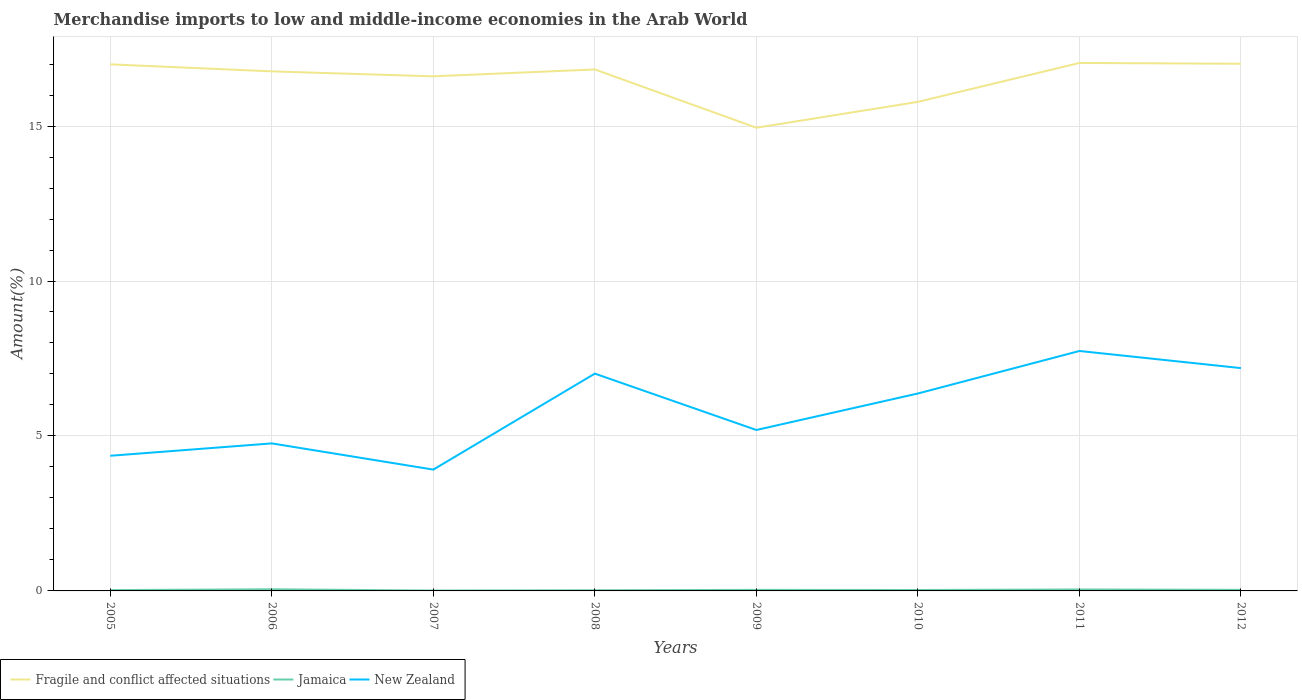How many different coloured lines are there?
Provide a succinct answer. 3. Does the line corresponding to New Zealand intersect with the line corresponding to Jamaica?
Offer a very short reply. No. Across all years, what is the maximum percentage of amount earned from merchandise imports in Fragile and conflict affected situations?
Provide a succinct answer. 14.95. In which year was the percentage of amount earned from merchandise imports in New Zealand maximum?
Keep it short and to the point. 2007. What is the total percentage of amount earned from merchandise imports in New Zealand in the graph?
Provide a short and direct response. -2.01. What is the difference between the highest and the second highest percentage of amount earned from merchandise imports in New Zealand?
Make the answer very short. 3.83. What is the difference between the highest and the lowest percentage of amount earned from merchandise imports in Fragile and conflict affected situations?
Your answer should be compact. 6. How many lines are there?
Your answer should be compact. 3. Are the values on the major ticks of Y-axis written in scientific E-notation?
Provide a succinct answer. No. Where does the legend appear in the graph?
Offer a very short reply. Bottom left. How are the legend labels stacked?
Provide a short and direct response. Horizontal. What is the title of the graph?
Your response must be concise. Merchandise imports to low and middle-income economies in the Arab World. What is the label or title of the X-axis?
Your answer should be compact. Years. What is the label or title of the Y-axis?
Offer a terse response. Amount(%). What is the Amount(%) of Fragile and conflict affected situations in 2005?
Give a very brief answer. 16.99. What is the Amount(%) in Jamaica in 2005?
Provide a succinct answer. 0.03. What is the Amount(%) in New Zealand in 2005?
Offer a very short reply. 4.36. What is the Amount(%) in Fragile and conflict affected situations in 2006?
Your answer should be compact. 16.76. What is the Amount(%) in Jamaica in 2006?
Offer a very short reply. 0.05. What is the Amount(%) of New Zealand in 2006?
Your response must be concise. 4.76. What is the Amount(%) in Fragile and conflict affected situations in 2007?
Provide a short and direct response. 16.6. What is the Amount(%) in Jamaica in 2007?
Your response must be concise. 0.01. What is the Amount(%) in New Zealand in 2007?
Offer a very short reply. 3.91. What is the Amount(%) in Fragile and conflict affected situations in 2008?
Offer a very short reply. 16.83. What is the Amount(%) of Jamaica in 2008?
Your answer should be very brief. 0.02. What is the Amount(%) in New Zealand in 2008?
Your response must be concise. 7.01. What is the Amount(%) of Fragile and conflict affected situations in 2009?
Your answer should be compact. 14.95. What is the Amount(%) in Jamaica in 2009?
Give a very brief answer. 0.03. What is the Amount(%) of New Zealand in 2009?
Offer a terse response. 5.19. What is the Amount(%) of Fragile and conflict affected situations in 2010?
Your answer should be compact. 15.78. What is the Amount(%) of Jamaica in 2010?
Give a very brief answer. 0.03. What is the Amount(%) in New Zealand in 2010?
Give a very brief answer. 6.37. What is the Amount(%) in Fragile and conflict affected situations in 2011?
Your answer should be compact. 17.04. What is the Amount(%) of Jamaica in 2011?
Provide a succinct answer. 0.05. What is the Amount(%) of New Zealand in 2011?
Offer a very short reply. 7.74. What is the Amount(%) in Fragile and conflict affected situations in 2012?
Your response must be concise. 17.01. What is the Amount(%) in Jamaica in 2012?
Ensure brevity in your answer.  0.03. What is the Amount(%) of New Zealand in 2012?
Your answer should be compact. 7.19. Across all years, what is the maximum Amount(%) in Fragile and conflict affected situations?
Your answer should be compact. 17.04. Across all years, what is the maximum Amount(%) in Jamaica?
Your answer should be compact. 0.05. Across all years, what is the maximum Amount(%) in New Zealand?
Offer a very short reply. 7.74. Across all years, what is the minimum Amount(%) in Fragile and conflict affected situations?
Make the answer very short. 14.95. Across all years, what is the minimum Amount(%) in Jamaica?
Your answer should be very brief. 0.01. Across all years, what is the minimum Amount(%) of New Zealand?
Make the answer very short. 3.91. What is the total Amount(%) of Fragile and conflict affected situations in the graph?
Ensure brevity in your answer.  131.96. What is the total Amount(%) of Jamaica in the graph?
Your answer should be very brief. 0.26. What is the total Amount(%) in New Zealand in the graph?
Keep it short and to the point. 46.54. What is the difference between the Amount(%) of Fragile and conflict affected situations in 2005 and that in 2006?
Give a very brief answer. 0.23. What is the difference between the Amount(%) in Jamaica in 2005 and that in 2006?
Make the answer very short. -0.03. What is the difference between the Amount(%) of New Zealand in 2005 and that in 2006?
Give a very brief answer. -0.4. What is the difference between the Amount(%) of Fragile and conflict affected situations in 2005 and that in 2007?
Offer a very short reply. 0.39. What is the difference between the Amount(%) in Jamaica in 2005 and that in 2007?
Your response must be concise. 0.01. What is the difference between the Amount(%) in New Zealand in 2005 and that in 2007?
Your response must be concise. 0.45. What is the difference between the Amount(%) in Fragile and conflict affected situations in 2005 and that in 2008?
Keep it short and to the point. 0.16. What is the difference between the Amount(%) of Jamaica in 2005 and that in 2008?
Keep it short and to the point. 0.01. What is the difference between the Amount(%) in New Zealand in 2005 and that in 2008?
Give a very brief answer. -2.65. What is the difference between the Amount(%) in Fragile and conflict affected situations in 2005 and that in 2009?
Give a very brief answer. 2.04. What is the difference between the Amount(%) in Jamaica in 2005 and that in 2009?
Your answer should be very brief. -0.01. What is the difference between the Amount(%) in New Zealand in 2005 and that in 2009?
Your answer should be compact. -0.83. What is the difference between the Amount(%) in Fragile and conflict affected situations in 2005 and that in 2010?
Make the answer very short. 1.21. What is the difference between the Amount(%) in Jamaica in 2005 and that in 2010?
Your answer should be compact. -0. What is the difference between the Amount(%) in New Zealand in 2005 and that in 2010?
Give a very brief answer. -2.01. What is the difference between the Amount(%) of Fragile and conflict affected situations in 2005 and that in 2011?
Ensure brevity in your answer.  -0.04. What is the difference between the Amount(%) in Jamaica in 2005 and that in 2011?
Keep it short and to the point. -0.02. What is the difference between the Amount(%) of New Zealand in 2005 and that in 2011?
Ensure brevity in your answer.  -3.38. What is the difference between the Amount(%) in Fragile and conflict affected situations in 2005 and that in 2012?
Offer a terse response. -0.02. What is the difference between the Amount(%) of Jamaica in 2005 and that in 2012?
Offer a very short reply. -0.01. What is the difference between the Amount(%) in New Zealand in 2005 and that in 2012?
Offer a terse response. -2.83. What is the difference between the Amount(%) of Fragile and conflict affected situations in 2006 and that in 2007?
Your answer should be compact. 0.16. What is the difference between the Amount(%) in Jamaica in 2006 and that in 2007?
Your answer should be very brief. 0.04. What is the difference between the Amount(%) in New Zealand in 2006 and that in 2007?
Offer a terse response. 0.85. What is the difference between the Amount(%) of Fragile and conflict affected situations in 2006 and that in 2008?
Make the answer very short. -0.06. What is the difference between the Amount(%) in Jamaica in 2006 and that in 2008?
Your response must be concise. 0.03. What is the difference between the Amount(%) in New Zealand in 2006 and that in 2008?
Your answer should be very brief. -2.25. What is the difference between the Amount(%) of Fragile and conflict affected situations in 2006 and that in 2009?
Keep it short and to the point. 1.82. What is the difference between the Amount(%) in Jamaica in 2006 and that in 2009?
Provide a short and direct response. 0.02. What is the difference between the Amount(%) in New Zealand in 2006 and that in 2009?
Keep it short and to the point. -0.43. What is the difference between the Amount(%) in Fragile and conflict affected situations in 2006 and that in 2010?
Ensure brevity in your answer.  0.98. What is the difference between the Amount(%) in Jamaica in 2006 and that in 2010?
Your answer should be very brief. 0.02. What is the difference between the Amount(%) of New Zealand in 2006 and that in 2010?
Your answer should be very brief. -1.61. What is the difference between the Amount(%) of Fragile and conflict affected situations in 2006 and that in 2011?
Offer a terse response. -0.27. What is the difference between the Amount(%) of Jamaica in 2006 and that in 2011?
Offer a terse response. 0.01. What is the difference between the Amount(%) of New Zealand in 2006 and that in 2011?
Your answer should be compact. -2.98. What is the difference between the Amount(%) of Fragile and conflict affected situations in 2006 and that in 2012?
Your answer should be compact. -0.25. What is the difference between the Amount(%) in Jamaica in 2006 and that in 2012?
Ensure brevity in your answer.  0.02. What is the difference between the Amount(%) of New Zealand in 2006 and that in 2012?
Provide a succinct answer. -2.43. What is the difference between the Amount(%) of Fragile and conflict affected situations in 2007 and that in 2008?
Provide a succinct answer. -0.22. What is the difference between the Amount(%) in Jamaica in 2007 and that in 2008?
Provide a succinct answer. -0.01. What is the difference between the Amount(%) in New Zealand in 2007 and that in 2008?
Offer a very short reply. -3.1. What is the difference between the Amount(%) of Fragile and conflict affected situations in 2007 and that in 2009?
Give a very brief answer. 1.66. What is the difference between the Amount(%) of Jamaica in 2007 and that in 2009?
Offer a terse response. -0.02. What is the difference between the Amount(%) of New Zealand in 2007 and that in 2009?
Ensure brevity in your answer.  -1.28. What is the difference between the Amount(%) in Fragile and conflict affected situations in 2007 and that in 2010?
Make the answer very short. 0.82. What is the difference between the Amount(%) of Jamaica in 2007 and that in 2010?
Ensure brevity in your answer.  -0.02. What is the difference between the Amount(%) of New Zealand in 2007 and that in 2010?
Offer a very short reply. -2.46. What is the difference between the Amount(%) of Fragile and conflict affected situations in 2007 and that in 2011?
Ensure brevity in your answer.  -0.43. What is the difference between the Amount(%) of Jamaica in 2007 and that in 2011?
Your response must be concise. -0.03. What is the difference between the Amount(%) of New Zealand in 2007 and that in 2011?
Provide a succinct answer. -3.83. What is the difference between the Amount(%) in Fragile and conflict affected situations in 2007 and that in 2012?
Your response must be concise. -0.41. What is the difference between the Amount(%) of Jamaica in 2007 and that in 2012?
Provide a succinct answer. -0.02. What is the difference between the Amount(%) in New Zealand in 2007 and that in 2012?
Keep it short and to the point. -3.28. What is the difference between the Amount(%) in Fragile and conflict affected situations in 2008 and that in 2009?
Keep it short and to the point. 1.88. What is the difference between the Amount(%) of Jamaica in 2008 and that in 2009?
Your answer should be compact. -0.01. What is the difference between the Amount(%) in New Zealand in 2008 and that in 2009?
Your response must be concise. 1.82. What is the difference between the Amount(%) in Fragile and conflict affected situations in 2008 and that in 2010?
Your answer should be compact. 1.05. What is the difference between the Amount(%) of Jamaica in 2008 and that in 2010?
Your response must be concise. -0.01. What is the difference between the Amount(%) of New Zealand in 2008 and that in 2010?
Your response must be concise. 0.64. What is the difference between the Amount(%) in Fragile and conflict affected situations in 2008 and that in 2011?
Your answer should be very brief. -0.21. What is the difference between the Amount(%) in Jamaica in 2008 and that in 2011?
Provide a succinct answer. -0.02. What is the difference between the Amount(%) of New Zealand in 2008 and that in 2011?
Offer a terse response. -0.73. What is the difference between the Amount(%) of Fragile and conflict affected situations in 2008 and that in 2012?
Give a very brief answer. -0.18. What is the difference between the Amount(%) in Jamaica in 2008 and that in 2012?
Offer a terse response. -0.01. What is the difference between the Amount(%) of New Zealand in 2008 and that in 2012?
Your answer should be compact. -0.18. What is the difference between the Amount(%) of Fragile and conflict affected situations in 2009 and that in 2010?
Ensure brevity in your answer.  -0.83. What is the difference between the Amount(%) of Jamaica in 2009 and that in 2010?
Your answer should be compact. 0. What is the difference between the Amount(%) in New Zealand in 2009 and that in 2010?
Your response must be concise. -1.18. What is the difference between the Amount(%) in Fragile and conflict affected situations in 2009 and that in 2011?
Keep it short and to the point. -2.09. What is the difference between the Amount(%) of Jamaica in 2009 and that in 2011?
Keep it short and to the point. -0.01. What is the difference between the Amount(%) in New Zealand in 2009 and that in 2011?
Your response must be concise. -2.55. What is the difference between the Amount(%) in Fragile and conflict affected situations in 2009 and that in 2012?
Make the answer very short. -2.06. What is the difference between the Amount(%) of Jamaica in 2009 and that in 2012?
Provide a succinct answer. -0. What is the difference between the Amount(%) of New Zealand in 2009 and that in 2012?
Keep it short and to the point. -2. What is the difference between the Amount(%) of Fragile and conflict affected situations in 2010 and that in 2011?
Offer a terse response. -1.26. What is the difference between the Amount(%) in Jamaica in 2010 and that in 2011?
Keep it short and to the point. -0.02. What is the difference between the Amount(%) of New Zealand in 2010 and that in 2011?
Ensure brevity in your answer.  -1.37. What is the difference between the Amount(%) of Fragile and conflict affected situations in 2010 and that in 2012?
Provide a succinct answer. -1.23. What is the difference between the Amount(%) of Jamaica in 2010 and that in 2012?
Ensure brevity in your answer.  -0.01. What is the difference between the Amount(%) in New Zealand in 2010 and that in 2012?
Give a very brief answer. -0.82. What is the difference between the Amount(%) in Fragile and conflict affected situations in 2011 and that in 2012?
Provide a short and direct response. 0.03. What is the difference between the Amount(%) of Jamaica in 2011 and that in 2012?
Keep it short and to the point. 0.01. What is the difference between the Amount(%) of New Zealand in 2011 and that in 2012?
Your response must be concise. 0.55. What is the difference between the Amount(%) of Fragile and conflict affected situations in 2005 and the Amount(%) of Jamaica in 2006?
Your answer should be very brief. 16.94. What is the difference between the Amount(%) in Fragile and conflict affected situations in 2005 and the Amount(%) in New Zealand in 2006?
Keep it short and to the point. 12.23. What is the difference between the Amount(%) in Jamaica in 2005 and the Amount(%) in New Zealand in 2006?
Give a very brief answer. -4.73. What is the difference between the Amount(%) in Fragile and conflict affected situations in 2005 and the Amount(%) in Jamaica in 2007?
Offer a terse response. 16.98. What is the difference between the Amount(%) in Fragile and conflict affected situations in 2005 and the Amount(%) in New Zealand in 2007?
Keep it short and to the point. 13.08. What is the difference between the Amount(%) of Jamaica in 2005 and the Amount(%) of New Zealand in 2007?
Your answer should be very brief. -3.89. What is the difference between the Amount(%) in Fragile and conflict affected situations in 2005 and the Amount(%) in Jamaica in 2008?
Offer a terse response. 16.97. What is the difference between the Amount(%) in Fragile and conflict affected situations in 2005 and the Amount(%) in New Zealand in 2008?
Make the answer very short. 9.98. What is the difference between the Amount(%) of Jamaica in 2005 and the Amount(%) of New Zealand in 2008?
Your answer should be compact. -6.98. What is the difference between the Amount(%) in Fragile and conflict affected situations in 2005 and the Amount(%) in Jamaica in 2009?
Ensure brevity in your answer.  16.96. What is the difference between the Amount(%) in Fragile and conflict affected situations in 2005 and the Amount(%) in New Zealand in 2009?
Your answer should be compact. 11.8. What is the difference between the Amount(%) in Jamaica in 2005 and the Amount(%) in New Zealand in 2009?
Make the answer very short. -5.17. What is the difference between the Amount(%) of Fragile and conflict affected situations in 2005 and the Amount(%) of Jamaica in 2010?
Offer a very short reply. 16.96. What is the difference between the Amount(%) in Fragile and conflict affected situations in 2005 and the Amount(%) in New Zealand in 2010?
Your answer should be compact. 10.62. What is the difference between the Amount(%) in Jamaica in 2005 and the Amount(%) in New Zealand in 2010?
Give a very brief answer. -6.34. What is the difference between the Amount(%) of Fragile and conflict affected situations in 2005 and the Amount(%) of Jamaica in 2011?
Offer a very short reply. 16.94. What is the difference between the Amount(%) in Fragile and conflict affected situations in 2005 and the Amount(%) in New Zealand in 2011?
Your answer should be compact. 9.25. What is the difference between the Amount(%) in Jamaica in 2005 and the Amount(%) in New Zealand in 2011?
Ensure brevity in your answer.  -7.71. What is the difference between the Amount(%) of Fragile and conflict affected situations in 2005 and the Amount(%) of Jamaica in 2012?
Provide a succinct answer. 16.96. What is the difference between the Amount(%) in Fragile and conflict affected situations in 2005 and the Amount(%) in New Zealand in 2012?
Give a very brief answer. 9.8. What is the difference between the Amount(%) in Jamaica in 2005 and the Amount(%) in New Zealand in 2012?
Offer a terse response. -7.16. What is the difference between the Amount(%) in Fragile and conflict affected situations in 2006 and the Amount(%) in Jamaica in 2007?
Provide a short and direct response. 16.75. What is the difference between the Amount(%) of Fragile and conflict affected situations in 2006 and the Amount(%) of New Zealand in 2007?
Your response must be concise. 12.85. What is the difference between the Amount(%) of Jamaica in 2006 and the Amount(%) of New Zealand in 2007?
Give a very brief answer. -3.86. What is the difference between the Amount(%) of Fragile and conflict affected situations in 2006 and the Amount(%) of Jamaica in 2008?
Provide a short and direct response. 16.74. What is the difference between the Amount(%) in Fragile and conflict affected situations in 2006 and the Amount(%) in New Zealand in 2008?
Ensure brevity in your answer.  9.75. What is the difference between the Amount(%) of Jamaica in 2006 and the Amount(%) of New Zealand in 2008?
Provide a succinct answer. -6.96. What is the difference between the Amount(%) in Fragile and conflict affected situations in 2006 and the Amount(%) in Jamaica in 2009?
Offer a terse response. 16.73. What is the difference between the Amount(%) in Fragile and conflict affected situations in 2006 and the Amount(%) in New Zealand in 2009?
Offer a terse response. 11.57. What is the difference between the Amount(%) of Jamaica in 2006 and the Amount(%) of New Zealand in 2009?
Provide a succinct answer. -5.14. What is the difference between the Amount(%) of Fragile and conflict affected situations in 2006 and the Amount(%) of Jamaica in 2010?
Offer a very short reply. 16.73. What is the difference between the Amount(%) of Fragile and conflict affected situations in 2006 and the Amount(%) of New Zealand in 2010?
Provide a short and direct response. 10.39. What is the difference between the Amount(%) of Jamaica in 2006 and the Amount(%) of New Zealand in 2010?
Your answer should be compact. -6.32. What is the difference between the Amount(%) of Fragile and conflict affected situations in 2006 and the Amount(%) of Jamaica in 2011?
Offer a very short reply. 16.72. What is the difference between the Amount(%) in Fragile and conflict affected situations in 2006 and the Amount(%) in New Zealand in 2011?
Ensure brevity in your answer.  9.02. What is the difference between the Amount(%) in Jamaica in 2006 and the Amount(%) in New Zealand in 2011?
Offer a very short reply. -7.69. What is the difference between the Amount(%) of Fragile and conflict affected situations in 2006 and the Amount(%) of Jamaica in 2012?
Offer a very short reply. 16.73. What is the difference between the Amount(%) in Fragile and conflict affected situations in 2006 and the Amount(%) in New Zealand in 2012?
Ensure brevity in your answer.  9.57. What is the difference between the Amount(%) in Jamaica in 2006 and the Amount(%) in New Zealand in 2012?
Keep it short and to the point. -7.14. What is the difference between the Amount(%) in Fragile and conflict affected situations in 2007 and the Amount(%) in Jamaica in 2008?
Keep it short and to the point. 16.58. What is the difference between the Amount(%) of Fragile and conflict affected situations in 2007 and the Amount(%) of New Zealand in 2008?
Provide a succinct answer. 9.59. What is the difference between the Amount(%) in Jamaica in 2007 and the Amount(%) in New Zealand in 2008?
Provide a short and direct response. -7. What is the difference between the Amount(%) of Fragile and conflict affected situations in 2007 and the Amount(%) of Jamaica in 2009?
Your response must be concise. 16.57. What is the difference between the Amount(%) in Fragile and conflict affected situations in 2007 and the Amount(%) in New Zealand in 2009?
Ensure brevity in your answer.  11.41. What is the difference between the Amount(%) in Jamaica in 2007 and the Amount(%) in New Zealand in 2009?
Your answer should be very brief. -5.18. What is the difference between the Amount(%) in Fragile and conflict affected situations in 2007 and the Amount(%) in Jamaica in 2010?
Provide a succinct answer. 16.57. What is the difference between the Amount(%) of Fragile and conflict affected situations in 2007 and the Amount(%) of New Zealand in 2010?
Keep it short and to the point. 10.23. What is the difference between the Amount(%) of Jamaica in 2007 and the Amount(%) of New Zealand in 2010?
Offer a terse response. -6.36. What is the difference between the Amount(%) of Fragile and conflict affected situations in 2007 and the Amount(%) of Jamaica in 2011?
Make the answer very short. 16.56. What is the difference between the Amount(%) in Fragile and conflict affected situations in 2007 and the Amount(%) in New Zealand in 2011?
Ensure brevity in your answer.  8.86. What is the difference between the Amount(%) of Jamaica in 2007 and the Amount(%) of New Zealand in 2011?
Give a very brief answer. -7.73. What is the difference between the Amount(%) in Fragile and conflict affected situations in 2007 and the Amount(%) in Jamaica in 2012?
Keep it short and to the point. 16.57. What is the difference between the Amount(%) of Fragile and conflict affected situations in 2007 and the Amount(%) of New Zealand in 2012?
Provide a succinct answer. 9.41. What is the difference between the Amount(%) in Jamaica in 2007 and the Amount(%) in New Zealand in 2012?
Give a very brief answer. -7.18. What is the difference between the Amount(%) of Fragile and conflict affected situations in 2008 and the Amount(%) of Jamaica in 2009?
Give a very brief answer. 16.79. What is the difference between the Amount(%) of Fragile and conflict affected situations in 2008 and the Amount(%) of New Zealand in 2009?
Provide a succinct answer. 11.63. What is the difference between the Amount(%) in Jamaica in 2008 and the Amount(%) in New Zealand in 2009?
Keep it short and to the point. -5.17. What is the difference between the Amount(%) in Fragile and conflict affected situations in 2008 and the Amount(%) in Jamaica in 2010?
Your answer should be very brief. 16.8. What is the difference between the Amount(%) of Fragile and conflict affected situations in 2008 and the Amount(%) of New Zealand in 2010?
Make the answer very short. 10.46. What is the difference between the Amount(%) in Jamaica in 2008 and the Amount(%) in New Zealand in 2010?
Provide a succinct answer. -6.35. What is the difference between the Amount(%) of Fragile and conflict affected situations in 2008 and the Amount(%) of Jamaica in 2011?
Provide a short and direct response. 16.78. What is the difference between the Amount(%) of Fragile and conflict affected situations in 2008 and the Amount(%) of New Zealand in 2011?
Provide a short and direct response. 9.08. What is the difference between the Amount(%) of Jamaica in 2008 and the Amount(%) of New Zealand in 2011?
Provide a succinct answer. -7.72. What is the difference between the Amount(%) in Fragile and conflict affected situations in 2008 and the Amount(%) in Jamaica in 2012?
Give a very brief answer. 16.79. What is the difference between the Amount(%) of Fragile and conflict affected situations in 2008 and the Amount(%) of New Zealand in 2012?
Make the answer very short. 9.64. What is the difference between the Amount(%) in Jamaica in 2008 and the Amount(%) in New Zealand in 2012?
Your answer should be very brief. -7.17. What is the difference between the Amount(%) of Fragile and conflict affected situations in 2009 and the Amount(%) of Jamaica in 2010?
Ensure brevity in your answer.  14.92. What is the difference between the Amount(%) in Fragile and conflict affected situations in 2009 and the Amount(%) in New Zealand in 2010?
Your response must be concise. 8.58. What is the difference between the Amount(%) of Jamaica in 2009 and the Amount(%) of New Zealand in 2010?
Offer a terse response. -6.34. What is the difference between the Amount(%) of Fragile and conflict affected situations in 2009 and the Amount(%) of Jamaica in 2011?
Offer a very short reply. 14.9. What is the difference between the Amount(%) of Fragile and conflict affected situations in 2009 and the Amount(%) of New Zealand in 2011?
Ensure brevity in your answer.  7.2. What is the difference between the Amount(%) of Jamaica in 2009 and the Amount(%) of New Zealand in 2011?
Your response must be concise. -7.71. What is the difference between the Amount(%) in Fragile and conflict affected situations in 2009 and the Amount(%) in Jamaica in 2012?
Your response must be concise. 14.91. What is the difference between the Amount(%) of Fragile and conflict affected situations in 2009 and the Amount(%) of New Zealand in 2012?
Provide a short and direct response. 7.76. What is the difference between the Amount(%) of Jamaica in 2009 and the Amount(%) of New Zealand in 2012?
Make the answer very short. -7.16. What is the difference between the Amount(%) of Fragile and conflict affected situations in 2010 and the Amount(%) of Jamaica in 2011?
Offer a very short reply. 15.73. What is the difference between the Amount(%) in Fragile and conflict affected situations in 2010 and the Amount(%) in New Zealand in 2011?
Your answer should be compact. 8.04. What is the difference between the Amount(%) of Jamaica in 2010 and the Amount(%) of New Zealand in 2011?
Provide a succinct answer. -7.71. What is the difference between the Amount(%) of Fragile and conflict affected situations in 2010 and the Amount(%) of Jamaica in 2012?
Make the answer very short. 15.75. What is the difference between the Amount(%) of Fragile and conflict affected situations in 2010 and the Amount(%) of New Zealand in 2012?
Give a very brief answer. 8.59. What is the difference between the Amount(%) of Jamaica in 2010 and the Amount(%) of New Zealand in 2012?
Provide a succinct answer. -7.16. What is the difference between the Amount(%) in Fragile and conflict affected situations in 2011 and the Amount(%) in Jamaica in 2012?
Provide a short and direct response. 17. What is the difference between the Amount(%) of Fragile and conflict affected situations in 2011 and the Amount(%) of New Zealand in 2012?
Your answer should be compact. 9.85. What is the difference between the Amount(%) of Jamaica in 2011 and the Amount(%) of New Zealand in 2012?
Your answer should be very brief. -7.14. What is the average Amount(%) in Fragile and conflict affected situations per year?
Make the answer very short. 16.49. What is the average Amount(%) of Jamaica per year?
Your response must be concise. 0.03. What is the average Amount(%) of New Zealand per year?
Provide a succinct answer. 5.82. In the year 2005, what is the difference between the Amount(%) of Fragile and conflict affected situations and Amount(%) of Jamaica?
Your answer should be very brief. 16.96. In the year 2005, what is the difference between the Amount(%) in Fragile and conflict affected situations and Amount(%) in New Zealand?
Offer a very short reply. 12.63. In the year 2005, what is the difference between the Amount(%) of Jamaica and Amount(%) of New Zealand?
Make the answer very short. -4.33. In the year 2006, what is the difference between the Amount(%) in Fragile and conflict affected situations and Amount(%) in Jamaica?
Keep it short and to the point. 16.71. In the year 2006, what is the difference between the Amount(%) of Fragile and conflict affected situations and Amount(%) of New Zealand?
Offer a terse response. 12. In the year 2006, what is the difference between the Amount(%) of Jamaica and Amount(%) of New Zealand?
Provide a short and direct response. -4.71. In the year 2007, what is the difference between the Amount(%) in Fragile and conflict affected situations and Amount(%) in Jamaica?
Your answer should be compact. 16.59. In the year 2007, what is the difference between the Amount(%) of Fragile and conflict affected situations and Amount(%) of New Zealand?
Keep it short and to the point. 12.69. In the year 2007, what is the difference between the Amount(%) in Jamaica and Amount(%) in New Zealand?
Provide a short and direct response. -3.9. In the year 2008, what is the difference between the Amount(%) in Fragile and conflict affected situations and Amount(%) in Jamaica?
Keep it short and to the point. 16.8. In the year 2008, what is the difference between the Amount(%) of Fragile and conflict affected situations and Amount(%) of New Zealand?
Your response must be concise. 9.81. In the year 2008, what is the difference between the Amount(%) of Jamaica and Amount(%) of New Zealand?
Make the answer very short. -6.99. In the year 2009, what is the difference between the Amount(%) in Fragile and conflict affected situations and Amount(%) in Jamaica?
Offer a very short reply. 14.91. In the year 2009, what is the difference between the Amount(%) of Fragile and conflict affected situations and Amount(%) of New Zealand?
Give a very brief answer. 9.75. In the year 2009, what is the difference between the Amount(%) in Jamaica and Amount(%) in New Zealand?
Your answer should be compact. -5.16. In the year 2010, what is the difference between the Amount(%) of Fragile and conflict affected situations and Amount(%) of Jamaica?
Offer a very short reply. 15.75. In the year 2010, what is the difference between the Amount(%) in Fragile and conflict affected situations and Amount(%) in New Zealand?
Keep it short and to the point. 9.41. In the year 2010, what is the difference between the Amount(%) in Jamaica and Amount(%) in New Zealand?
Keep it short and to the point. -6.34. In the year 2011, what is the difference between the Amount(%) in Fragile and conflict affected situations and Amount(%) in Jamaica?
Your response must be concise. 16.99. In the year 2011, what is the difference between the Amount(%) of Fragile and conflict affected situations and Amount(%) of New Zealand?
Make the answer very short. 9.29. In the year 2011, what is the difference between the Amount(%) of Jamaica and Amount(%) of New Zealand?
Your answer should be very brief. -7.7. In the year 2012, what is the difference between the Amount(%) of Fragile and conflict affected situations and Amount(%) of Jamaica?
Your answer should be very brief. 16.98. In the year 2012, what is the difference between the Amount(%) of Fragile and conflict affected situations and Amount(%) of New Zealand?
Offer a terse response. 9.82. In the year 2012, what is the difference between the Amount(%) of Jamaica and Amount(%) of New Zealand?
Ensure brevity in your answer.  -7.15. What is the ratio of the Amount(%) in Fragile and conflict affected situations in 2005 to that in 2006?
Your answer should be compact. 1.01. What is the ratio of the Amount(%) in Jamaica in 2005 to that in 2006?
Give a very brief answer. 0.51. What is the ratio of the Amount(%) of New Zealand in 2005 to that in 2006?
Offer a very short reply. 0.92. What is the ratio of the Amount(%) in Fragile and conflict affected situations in 2005 to that in 2007?
Provide a short and direct response. 1.02. What is the ratio of the Amount(%) of Jamaica in 2005 to that in 2007?
Ensure brevity in your answer.  2.21. What is the ratio of the Amount(%) in New Zealand in 2005 to that in 2007?
Your response must be concise. 1.11. What is the ratio of the Amount(%) of Fragile and conflict affected situations in 2005 to that in 2008?
Your answer should be very brief. 1.01. What is the ratio of the Amount(%) in Jamaica in 2005 to that in 2008?
Make the answer very short. 1.23. What is the ratio of the Amount(%) of New Zealand in 2005 to that in 2008?
Make the answer very short. 0.62. What is the ratio of the Amount(%) in Fragile and conflict affected situations in 2005 to that in 2009?
Offer a very short reply. 1.14. What is the ratio of the Amount(%) in Jamaica in 2005 to that in 2009?
Make the answer very short. 0.8. What is the ratio of the Amount(%) of New Zealand in 2005 to that in 2009?
Your response must be concise. 0.84. What is the ratio of the Amount(%) in Fragile and conflict affected situations in 2005 to that in 2010?
Provide a short and direct response. 1.08. What is the ratio of the Amount(%) in Jamaica in 2005 to that in 2010?
Your response must be concise. 0.91. What is the ratio of the Amount(%) in New Zealand in 2005 to that in 2010?
Keep it short and to the point. 0.68. What is the ratio of the Amount(%) in Fragile and conflict affected situations in 2005 to that in 2011?
Offer a very short reply. 1. What is the ratio of the Amount(%) in Jamaica in 2005 to that in 2011?
Provide a short and direct response. 0.58. What is the ratio of the Amount(%) in New Zealand in 2005 to that in 2011?
Provide a short and direct response. 0.56. What is the ratio of the Amount(%) in Fragile and conflict affected situations in 2005 to that in 2012?
Make the answer very short. 1. What is the ratio of the Amount(%) in Jamaica in 2005 to that in 2012?
Your response must be concise. 0.78. What is the ratio of the Amount(%) in New Zealand in 2005 to that in 2012?
Make the answer very short. 0.61. What is the ratio of the Amount(%) of Fragile and conflict affected situations in 2006 to that in 2007?
Give a very brief answer. 1.01. What is the ratio of the Amount(%) in Jamaica in 2006 to that in 2007?
Keep it short and to the point. 4.35. What is the ratio of the Amount(%) of New Zealand in 2006 to that in 2007?
Provide a succinct answer. 1.22. What is the ratio of the Amount(%) in Jamaica in 2006 to that in 2008?
Give a very brief answer. 2.42. What is the ratio of the Amount(%) of New Zealand in 2006 to that in 2008?
Keep it short and to the point. 0.68. What is the ratio of the Amount(%) in Fragile and conflict affected situations in 2006 to that in 2009?
Offer a terse response. 1.12. What is the ratio of the Amount(%) in Jamaica in 2006 to that in 2009?
Make the answer very short. 1.57. What is the ratio of the Amount(%) of Fragile and conflict affected situations in 2006 to that in 2010?
Your answer should be compact. 1.06. What is the ratio of the Amount(%) of Jamaica in 2006 to that in 2010?
Your answer should be compact. 1.79. What is the ratio of the Amount(%) of New Zealand in 2006 to that in 2010?
Ensure brevity in your answer.  0.75. What is the ratio of the Amount(%) in Fragile and conflict affected situations in 2006 to that in 2011?
Give a very brief answer. 0.98. What is the ratio of the Amount(%) in Jamaica in 2006 to that in 2011?
Make the answer very short. 1.13. What is the ratio of the Amount(%) in New Zealand in 2006 to that in 2011?
Provide a succinct answer. 0.61. What is the ratio of the Amount(%) of Fragile and conflict affected situations in 2006 to that in 2012?
Offer a terse response. 0.99. What is the ratio of the Amount(%) in Jamaica in 2006 to that in 2012?
Make the answer very short. 1.52. What is the ratio of the Amount(%) of New Zealand in 2006 to that in 2012?
Offer a very short reply. 0.66. What is the ratio of the Amount(%) of Fragile and conflict affected situations in 2007 to that in 2008?
Offer a very short reply. 0.99. What is the ratio of the Amount(%) of Jamaica in 2007 to that in 2008?
Make the answer very short. 0.56. What is the ratio of the Amount(%) of New Zealand in 2007 to that in 2008?
Keep it short and to the point. 0.56. What is the ratio of the Amount(%) of Fragile and conflict affected situations in 2007 to that in 2009?
Offer a terse response. 1.11. What is the ratio of the Amount(%) of Jamaica in 2007 to that in 2009?
Offer a very short reply. 0.36. What is the ratio of the Amount(%) in New Zealand in 2007 to that in 2009?
Your answer should be compact. 0.75. What is the ratio of the Amount(%) in Fragile and conflict affected situations in 2007 to that in 2010?
Your answer should be very brief. 1.05. What is the ratio of the Amount(%) in Jamaica in 2007 to that in 2010?
Give a very brief answer. 0.41. What is the ratio of the Amount(%) of New Zealand in 2007 to that in 2010?
Your answer should be compact. 0.61. What is the ratio of the Amount(%) in Fragile and conflict affected situations in 2007 to that in 2011?
Provide a short and direct response. 0.97. What is the ratio of the Amount(%) in Jamaica in 2007 to that in 2011?
Offer a very short reply. 0.26. What is the ratio of the Amount(%) of New Zealand in 2007 to that in 2011?
Your answer should be compact. 0.51. What is the ratio of the Amount(%) of Fragile and conflict affected situations in 2007 to that in 2012?
Your answer should be compact. 0.98. What is the ratio of the Amount(%) in Jamaica in 2007 to that in 2012?
Keep it short and to the point. 0.35. What is the ratio of the Amount(%) in New Zealand in 2007 to that in 2012?
Your answer should be compact. 0.54. What is the ratio of the Amount(%) in Fragile and conflict affected situations in 2008 to that in 2009?
Your answer should be compact. 1.13. What is the ratio of the Amount(%) in Jamaica in 2008 to that in 2009?
Keep it short and to the point. 0.65. What is the ratio of the Amount(%) in New Zealand in 2008 to that in 2009?
Provide a short and direct response. 1.35. What is the ratio of the Amount(%) of Fragile and conflict affected situations in 2008 to that in 2010?
Offer a very short reply. 1.07. What is the ratio of the Amount(%) in Jamaica in 2008 to that in 2010?
Provide a short and direct response. 0.74. What is the ratio of the Amount(%) in New Zealand in 2008 to that in 2010?
Your answer should be very brief. 1.1. What is the ratio of the Amount(%) of Jamaica in 2008 to that in 2011?
Offer a very short reply. 0.47. What is the ratio of the Amount(%) of New Zealand in 2008 to that in 2011?
Provide a short and direct response. 0.91. What is the ratio of the Amount(%) in Fragile and conflict affected situations in 2008 to that in 2012?
Your response must be concise. 0.99. What is the ratio of the Amount(%) in Jamaica in 2008 to that in 2012?
Make the answer very short. 0.63. What is the ratio of the Amount(%) of New Zealand in 2008 to that in 2012?
Make the answer very short. 0.98. What is the ratio of the Amount(%) of Fragile and conflict affected situations in 2009 to that in 2010?
Make the answer very short. 0.95. What is the ratio of the Amount(%) in Jamaica in 2009 to that in 2010?
Your answer should be very brief. 1.14. What is the ratio of the Amount(%) of New Zealand in 2009 to that in 2010?
Ensure brevity in your answer.  0.82. What is the ratio of the Amount(%) of Fragile and conflict affected situations in 2009 to that in 2011?
Offer a terse response. 0.88. What is the ratio of the Amount(%) in Jamaica in 2009 to that in 2011?
Give a very brief answer. 0.72. What is the ratio of the Amount(%) of New Zealand in 2009 to that in 2011?
Provide a succinct answer. 0.67. What is the ratio of the Amount(%) in Fragile and conflict affected situations in 2009 to that in 2012?
Ensure brevity in your answer.  0.88. What is the ratio of the Amount(%) of Jamaica in 2009 to that in 2012?
Offer a terse response. 0.97. What is the ratio of the Amount(%) of New Zealand in 2009 to that in 2012?
Give a very brief answer. 0.72. What is the ratio of the Amount(%) of Fragile and conflict affected situations in 2010 to that in 2011?
Your answer should be compact. 0.93. What is the ratio of the Amount(%) in Jamaica in 2010 to that in 2011?
Ensure brevity in your answer.  0.64. What is the ratio of the Amount(%) in New Zealand in 2010 to that in 2011?
Your answer should be very brief. 0.82. What is the ratio of the Amount(%) in Fragile and conflict affected situations in 2010 to that in 2012?
Make the answer very short. 0.93. What is the ratio of the Amount(%) in Jamaica in 2010 to that in 2012?
Keep it short and to the point. 0.85. What is the ratio of the Amount(%) in New Zealand in 2010 to that in 2012?
Offer a very short reply. 0.89. What is the ratio of the Amount(%) in Jamaica in 2011 to that in 2012?
Make the answer very short. 1.34. What is the ratio of the Amount(%) in New Zealand in 2011 to that in 2012?
Give a very brief answer. 1.08. What is the difference between the highest and the second highest Amount(%) of Fragile and conflict affected situations?
Keep it short and to the point. 0.03. What is the difference between the highest and the second highest Amount(%) in Jamaica?
Provide a succinct answer. 0.01. What is the difference between the highest and the second highest Amount(%) in New Zealand?
Ensure brevity in your answer.  0.55. What is the difference between the highest and the lowest Amount(%) of Fragile and conflict affected situations?
Provide a succinct answer. 2.09. What is the difference between the highest and the lowest Amount(%) in Jamaica?
Offer a very short reply. 0.04. What is the difference between the highest and the lowest Amount(%) of New Zealand?
Make the answer very short. 3.83. 